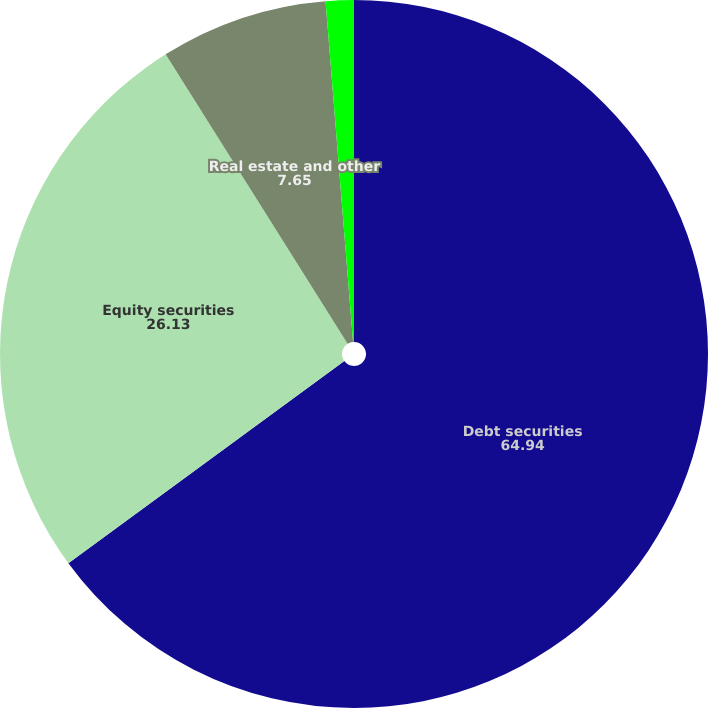Convert chart to OTSL. <chart><loc_0><loc_0><loc_500><loc_500><pie_chart><fcel>Debt securities<fcel>Equity securities<fcel>Real estate and other<fcel>Total<nl><fcel>64.94%<fcel>26.13%<fcel>7.65%<fcel>1.28%<nl></chart> 